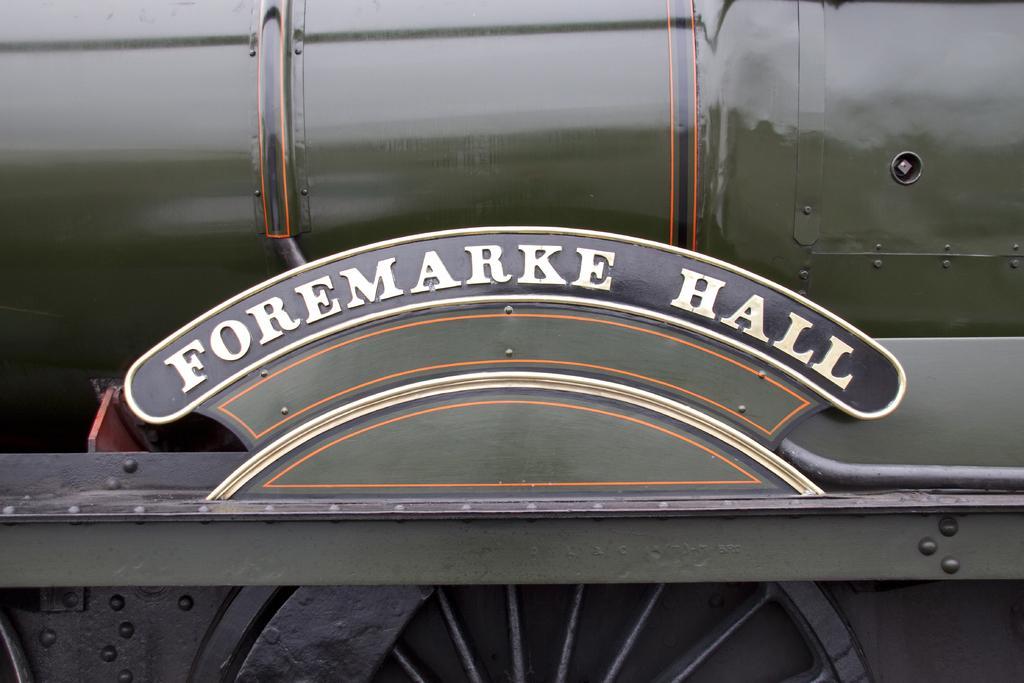How would you summarize this image in a sentence or two? This image consists of a train in green color. At the bottom, there is a wheel. In the front, we can see a name board. 